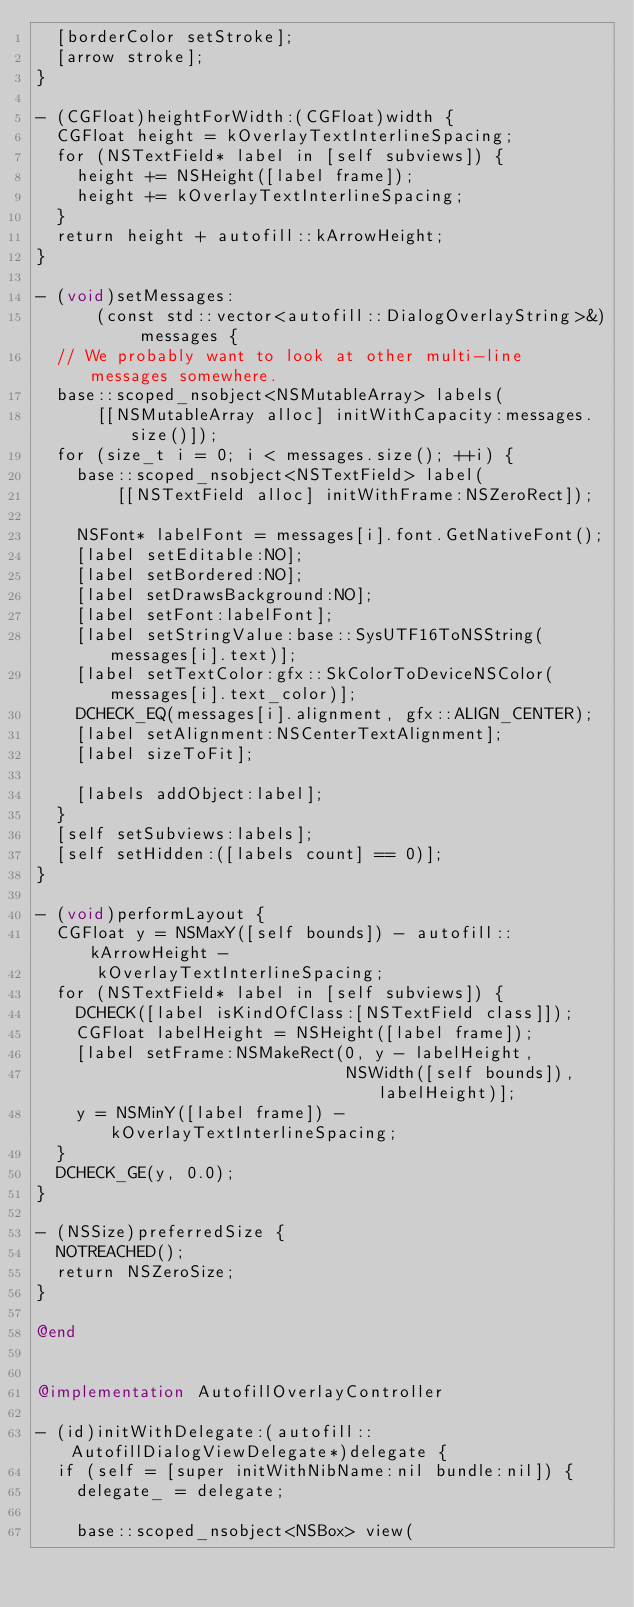<code> <loc_0><loc_0><loc_500><loc_500><_ObjectiveC_>  [borderColor setStroke];
  [arrow stroke];
}

- (CGFloat)heightForWidth:(CGFloat)width {
  CGFloat height = kOverlayTextInterlineSpacing;
  for (NSTextField* label in [self subviews]) {
    height += NSHeight([label frame]);
    height += kOverlayTextInterlineSpacing;
  }
  return height + autofill::kArrowHeight;
}

- (void)setMessages:
      (const std::vector<autofill::DialogOverlayString>&) messages {
  // We probably want to look at other multi-line messages somewhere.
  base::scoped_nsobject<NSMutableArray> labels(
      [[NSMutableArray alloc] initWithCapacity:messages.size()]);
  for (size_t i = 0; i < messages.size(); ++i) {
    base::scoped_nsobject<NSTextField> label(
        [[NSTextField alloc] initWithFrame:NSZeroRect]);

    NSFont* labelFont = messages[i].font.GetNativeFont();
    [label setEditable:NO];
    [label setBordered:NO];
    [label setDrawsBackground:NO];
    [label setFont:labelFont];
    [label setStringValue:base::SysUTF16ToNSString(messages[i].text)];
    [label setTextColor:gfx::SkColorToDeviceNSColor(messages[i].text_color)];
    DCHECK_EQ(messages[i].alignment, gfx::ALIGN_CENTER);
    [label setAlignment:NSCenterTextAlignment];
    [label sizeToFit];

    [labels addObject:label];
  }
  [self setSubviews:labels];
  [self setHidden:([labels count] == 0)];
}

- (void)performLayout {
  CGFloat y = NSMaxY([self bounds]) - autofill::kArrowHeight -
      kOverlayTextInterlineSpacing;
  for (NSTextField* label in [self subviews]) {
    DCHECK([label isKindOfClass:[NSTextField class]]);
    CGFloat labelHeight = NSHeight([label frame]);
    [label setFrame:NSMakeRect(0, y - labelHeight,
                               NSWidth([self bounds]), labelHeight)];
    y = NSMinY([label frame]) - kOverlayTextInterlineSpacing;
  }
  DCHECK_GE(y, 0.0);
}

- (NSSize)preferredSize {
  NOTREACHED();
  return NSZeroSize;
}

@end


@implementation AutofillOverlayController

- (id)initWithDelegate:(autofill::AutofillDialogViewDelegate*)delegate {
  if (self = [super initWithNibName:nil bundle:nil]) {
    delegate_ = delegate;

    base::scoped_nsobject<NSBox> view(</code> 